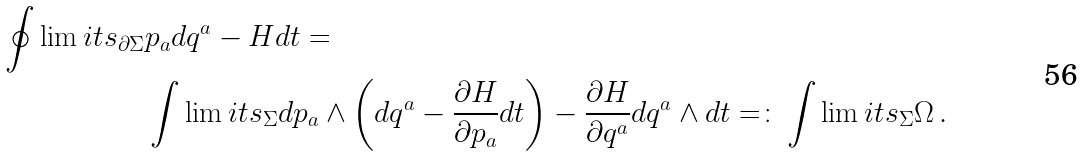<formula> <loc_0><loc_0><loc_500><loc_500>\oint \lim i t s _ { \partial \Sigma } & p _ { a } d q ^ { a } - H d t = \\ & \int \lim i t s _ { \Sigma } d p _ { a } \wedge \left ( d q ^ { a } - \frac { \partial H } { \partial p _ { a } } d t \right ) - \frac { \partial H } { \partial q ^ { a } } d q ^ { a } \wedge d t = \colon \int \lim i t s _ { \Sigma } \Omega \, .</formula> 